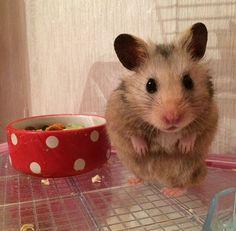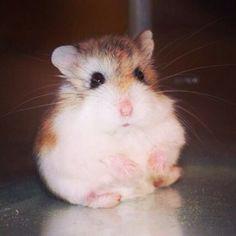The first image is the image on the left, the second image is the image on the right. Considering the images on both sides, is "Right image shows one pet rodent posed with both front paws off the ground in front of its chest." valid? Answer yes or no. Yes. The first image is the image on the left, the second image is the image on the right. Given the left and right images, does the statement "One of the images features some of the hamster's food." hold true? Answer yes or no. Yes. 